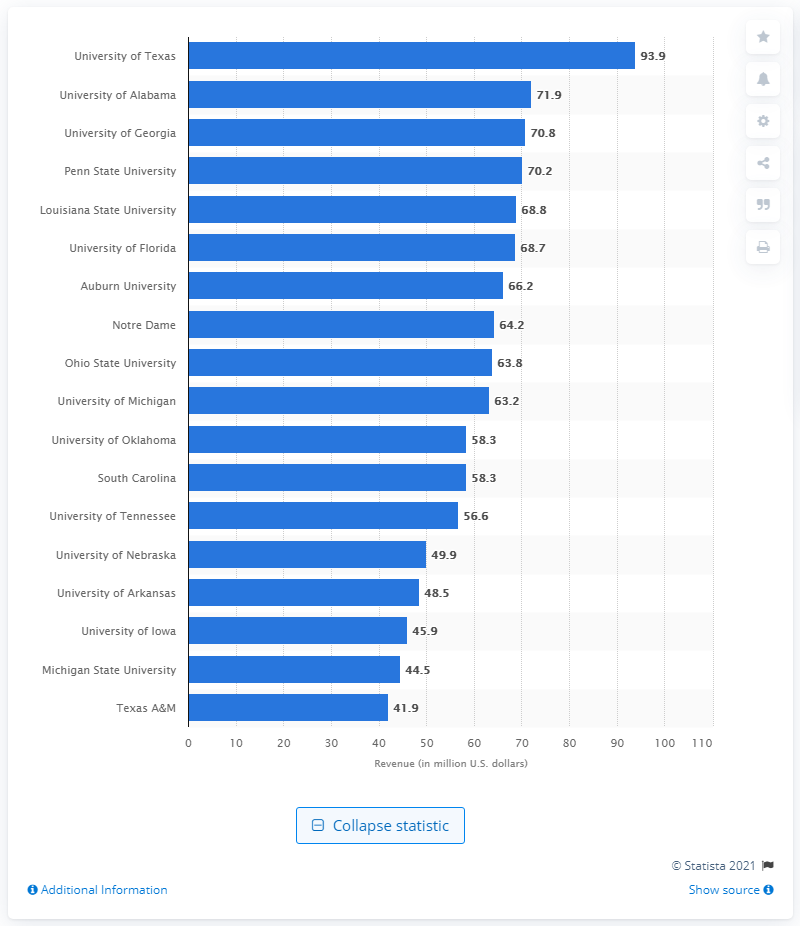What is the highest revenue generated by a university in this chart? The highest revenue generated by a university in the chart is approximately $93.9 million, achieved by the University of Texas. 